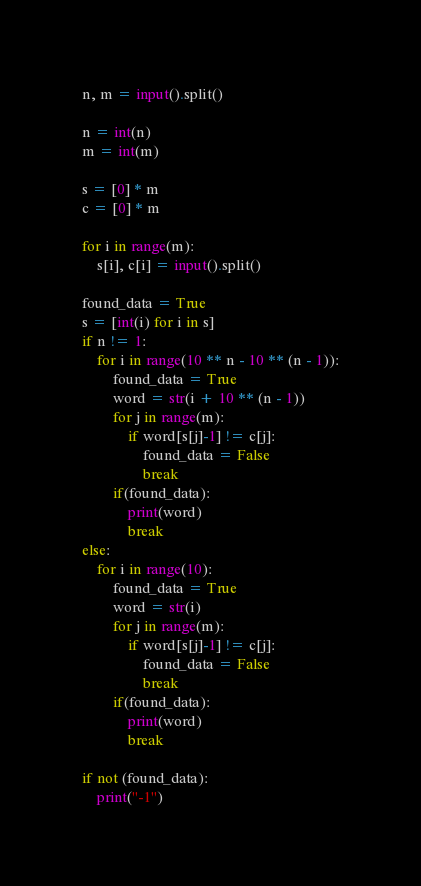Convert code to text. <code><loc_0><loc_0><loc_500><loc_500><_Python_>n, m = input().split()

n = int(n)
m = int(m)

s = [0] * m
c = [0] * m

for i in range(m):
    s[i], c[i] = input().split()

found_data = True
s = [int(i) for i in s]
if n != 1:
    for i in range(10 ** n - 10 ** (n - 1)):
        found_data = True
        word = str(i + 10 ** (n - 1))
        for j in range(m):
            if word[s[j]-1] != c[j]:
                found_data = False
                break
        if(found_data):
            print(word)
            break
else:
    for i in range(10):
        found_data = True
        word = str(i)
        for j in range(m):
            if word[s[j]-1] != c[j]:
                found_data = False
                break
        if(found_data):
            print(word)
            break

if not (found_data):
    print("-1")
</code> 